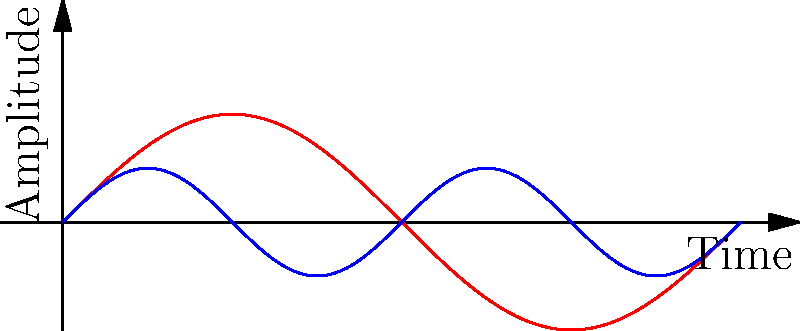Analyzing the waveforms displayed on the oscilloscope, which signal has a higher frequency? Explain your reasoning based on the characteristics of the waveforms. To determine which signal has a higher frequency, we need to analyze the waveforms:

1. Observe the number of cycles: 
   - Signal A (red) completes one full cycle in the given time frame.
   - Signal B (blue) completes two full cycles in the same time frame.

2. Understand the relationship between frequency and cycles:
   - Frequency is directly proportional to the number of cycles completed in a given time period.
   - More cycles in the same time period indicate a higher frequency.

3. Compare the signals:
   - Signal B completes more cycles than Signal A in the same time period.
   - Therefore, Signal B has a higher frequency than Signal A.

4. Additional observations:
   - Signal B has a shorter wavelength (distance between peaks) than Signal A.
   - Shorter wavelength corresponds to higher frequency, confirming our conclusion.

5. Mathematical representation:
   - If we assume the time frame is $2\pi$ seconds, Signal A's frequency would be $f_A = \frac{1}{2\pi}$ Hz.
   - Signal B's frequency would be $f_B = \frac{2}{2\pi} = \frac{1}{\pi}$ Hz.
   - $f_B > f_A$, confirming Signal B has a higher frequency.
Answer: Signal B (blue) 